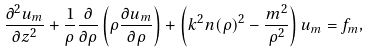<formula> <loc_0><loc_0><loc_500><loc_500>\frac { \partial ^ { 2 } u _ { m } } { \partial z ^ { 2 } } + \frac { 1 } { \rho } \frac { \partial } { \partial \rho } \left ( \rho \frac { \partial u _ { m } } { \partial \rho } \right ) + \left ( k ^ { 2 } n ( \rho ) ^ { 2 } - \frac { m ^ { 2 } } { \rho ^ { 2 } } \right ) u _ { m } = f _ { m } ,</formula> 